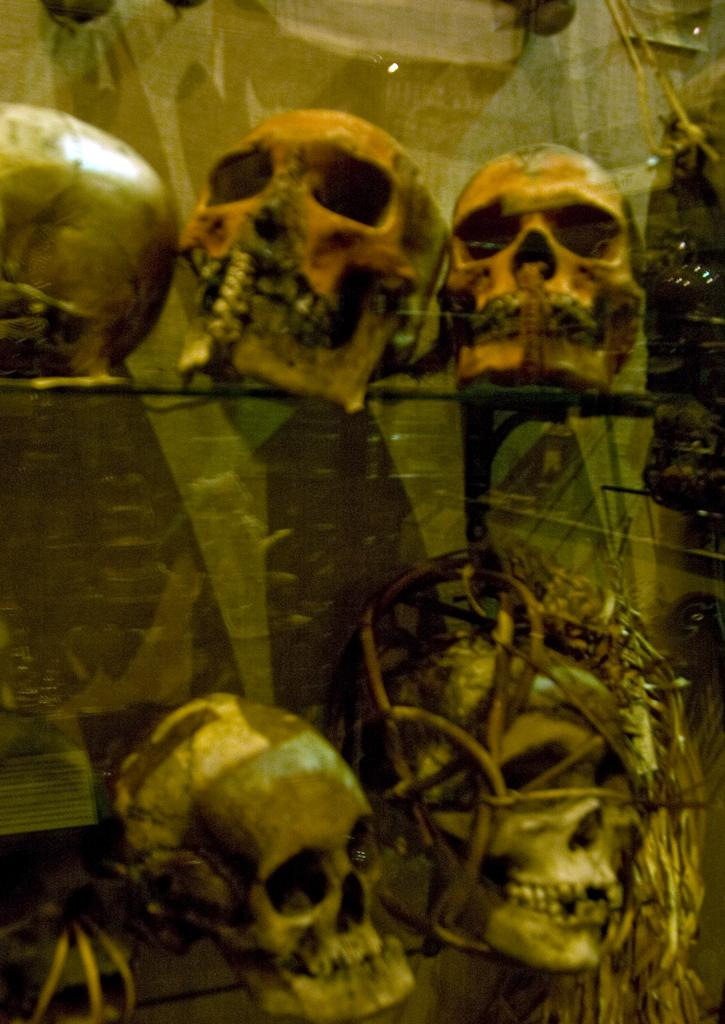What objects are present in the image? There are skulls in the image. Where are the skulls located? The skulls are in shelves. What type of fireman is depicted on the edge of the shelf in the image? There is no fireman present in the image; it only features skulls on shelves. 